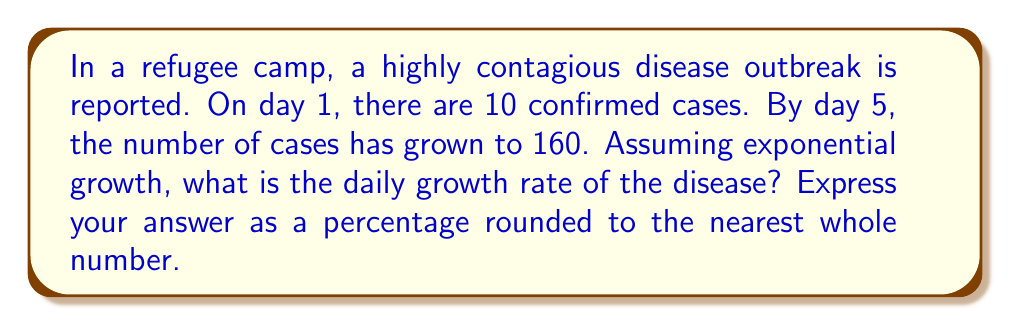Solve this math problem. Let's approach this step-by-step:

1) The exponential growth formula is:
   $$P(t) = P_0 \cdot (1 + r)^t$$
   where $P(t)$ is the population at time $t$, $P_0$ is the initial population, $r$ is the daily growth rate, and $t$ is the number of days.

2) We know:
   $P_0 = 10$ (initial cases)
   $P(5) = 160$ (cases after 5 days)
   $t = 5$ (days)

3) Plugging these into the formula:
   $$160 = 10 \cdot (1 + r)^5$$

4) Divide both sides by 10:
   $$16 = (1 + r)^5$$

5) Take the 5th root of both sides:
   $$\sqrt[5]{16} = 1 + r$$

6) Solve for $r$:
   $$r = \sqrt[5]{16} - 1$$

7) Calculate:
   $$r \approx 1.3195 - 1 = 0.3195$$

8) Convert to percentage:
   $$0.3195 \times 100 \approx 31.95\%$$

9) Rounding to the nearest whole number:
   $$31.95\% \approx 32\%$$
Answer: 32% 